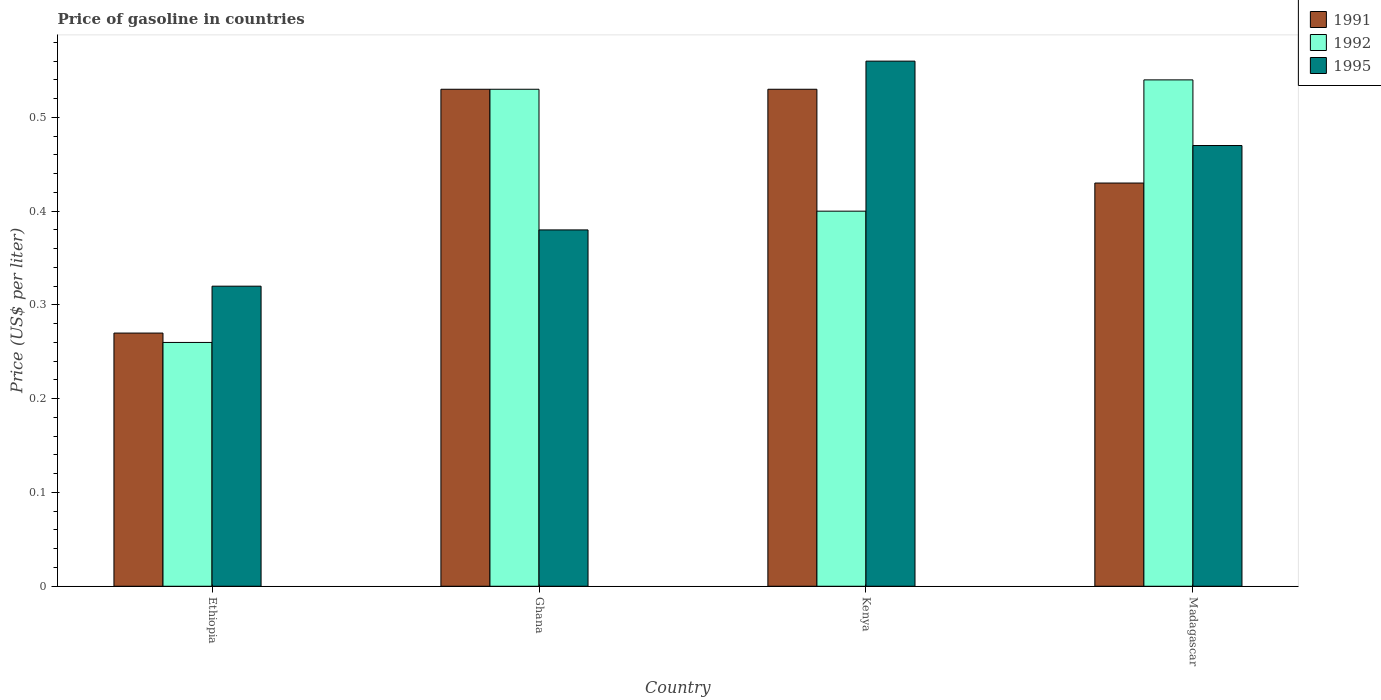How many different coloured bars are there?
Provide a succinct answer. 3. Are the number of bars on each tick of the X-axis equal?
Your answer should be compact. Yes. What is the label of the 1st group of bars from the left?
Ensure brevity in your answer.  Ethiopia. What is the price of gasoline in 1991 in Ghana?
Your answer should be compact. 0.53. Across all countries, what is the maximum price of gasoline in 1992?
Give a very brief answer. 0.54. Across all countries, what is the minimum price of gasoline in 1995?
Ensure brevity in your answer.  0.32. In which country was the price of gasoline in 1995 maximum?
Provide a succinct answer. Kenya. In which country was the price of gasoline in 1995 minimum?
Offer a very short reply. Ethiopia. What is the total price of gasoline in 1995 in the graph?
Provide a short and direct response. 1.73. What is the difference between the price of gasoline in 1995 in Kenya and that in Madagascar?
Provide a succinct answer. 0.09. What is the difference between the price of gasoline in 1991 in Madagascar and the price of gasoline in 1995 in Ghana?
Ensure brevity in your answer.  0.05. What is the average price of gasoline in 1995 per country?
Your answer should be compact. 0.43. What is the difference between the price of gasoline of/in 1991 and price of gasoline of/in 1992 in Madagascar?
Your answer should be compact. -0.11. What is the ratio of the price of gasoline in 1992 in Ghana to that in Kenya?
Ensure brevity in your answer.  1.32. Is the difference between the price of gasoline in 1991 in Ethiopia and Ghana greater than the difference between the price of gasoline in 1992 in Ethiopia and Ghana?
Your answer should be compact. Yes. What is the difference between the highest and the second highest price of gasoline in 1991?
Provide a succinct answer. 0.1. What is the difference between the highest and the lowest price of gasoline in 1995?
Offer a terse response. 0.24. In how many countries, is the price of gasoline in 1995 greater than the average price of gasoline in 1995 taken over all countries?
Your response must be concise. 2. Is the sum of the price of gasoline in 1992 in Ghana and Madagascar greater than the maximum price of gasoline in 1991 across all countries?
Your answer should be very brief. Yes. What does the 2nd bar from the left in Ghana represents?
Provide a short and direct response. 1992. Is it the case that in every country, the sum of the price of gasoline in 1991 and price of gasoline in 1995 is greater than the price of gasoline in 1992?
Make the answer very short. Yes. How many bars are there?
Your response must be concise. 12. How many countries are there in the graph?
Keep it short and to the point. 4. Does the graph contain any zero values?
Your answer should be compact. No. Where does the legend appear in the graph?
Give a very brief answer. Top right. How many legend labels are there?
Your answer should be compact. 3. What is the title of the graph?
Keep it short and to the point. Price of gasoline in countries. What is the label or title of the X-axis?
Your response must be concise. Country. What is the label or title of the Y-axis?
Your answer should be very brief. Price (US$ per liter). What is the Price (US$ per liter) in 1991 in Ethiopia?
Provide a short and direct response. 0.27. What is the Price (US$ per liter) in 1992 in Ethiopia?
Provide a succinct answer. 0.26. What is the Price (US$ per liter) of 1995 in Ethiopia?
Keep it short and to the point. 0.32. What is the Price (US$ per liter) in 1991 in Ghana?
Offer a very short reply. 0.53. What is the Price (US$ per liter) of 1992 in Ghana?
Your answer should be very brief. 0.53. What is the Price (US$ per liter) of 1995 in Ghana?
Provide a succinct answer. 0.38. What is the Price (US$ per liter) of 1991 in Kenya?
Give a very brief answer. 0.53. What is the Price (US$ per liter) of 1992 in Kenya?
Offer a very short reply. 0.4. What is the Price (US$ per liter) of 1995 in Kenya?
Keep it short and to the point. 0.56. What is the Price (US$ per liter) of 1991 in Madagascar?
Make the answer very short. 0.43. What is the Price (US$ per liter) in 1992 in Madagascar?
Give a very brief answer. 0.54. What is the Price (US$ per liter) of 1995 in Madagascar?
Give a very brief answer. 0.47. Across all countries, what is the maximum Price (US$ per liter) of 1991?
Your answer should be very brief. 0.53. Across all countries, what is the maximum Price (US$ per liter) of 1992?
Your answer should be very brief. 0.54. Across all countries, what is the maximum Price (US$ per liter) in 1995?
Offer a terse response. 0.56. Across all countries, what is the minimum Price (US$ per liter) in 1991?
Offer a terse response. 0.27. Across all countries, what is the minimum Price (US$ per liter) of 1992?
Offer a very short reply. 0.26. Across all countries, what is the minimum Price (US$ per liter) in 1995?
Your answer should be very brief. 0.32. What is the total Price (US$ per liter) of 1991 in the graph?
Provide a short and direct response. 1.76. What is the total Price (US$ per liter) of 1992 in the graph?
Offer a very short reply. 1.73. What is the total Price (US$ per liter) in 1995 in the graph?
Keep it short and to the point. 1.73. What is the difference between the Price (US$ per liter) in 1991 in Ethiopia and that in Ghana?
Offer a terse response. -0.26. What is the difference between the Price (US$ per liter) of 1992 in Ethiopia and that in Ghana?
Offer a terse response. -0.27. What is the difference between the Price (US$ per liter) of 1995 in Ethiopia and that in Ghana?
Ensure brevity in your answer.  -0.06. What is the difference between the Price (US$ per liter) in 1991 in Ethiopia and that in Kenya?
Your answer should be compact. -0.26. What is the difference between the Price (US$ per liter) of 1992 in Ethiopia and that in Kenya?
Provide a short and direct response. -0.14. What is the difference between the Price (US$ per liter) of 1995 in Ethiopia and that in Kenya?
Offer a terse response. -0.24. What is the difference between the Price (US$ per liter) in 1991 in Ethiopia and that in Madagascar?
Make the answer very short. -0.16. What is the difference between the Price (US$ per liter) of 1992 in Ethiopia and that in Madagascar?
Your answer should be compact. -0.28. What is the difference between the Price (US$ per liter) of 1992 in Ghana and that in Kenya?
Your answer should be very brief. 0.13. What is the difference between the Price (US$ per liter) in 1995 in Ghana and that in Kenya?
Your answer should be compact. -0.18. What is the difference between the Price (US$ per liter) of 1991 in Ghana and that in Madagascar?
Keep it short and to the point. 0.1. What is the difference between the Price (US$ per liter) of 1992 in Ghana and that in Madagascar?
Give a very brief answer. -0.01. What is the difference between the Price (US$ per liter) of 1995 in Ghana and that in Madagascar?
Offer a very short reply. -0.09. What is the difference between the Price (US$ per liter) of 1991 in Kenya and that in Madagascar?
Your response must be concise. 0.1. What is the difference between the Price (US$ per liter) in 1992 in Kenya and that in Madagascar?
Offer a very short reply. -0.14. What is the difference between the Price (US$ per liter) in 1995 in Kenya and that in Madagascar?
Offer a terse response. 0.09. What is the difference between the Price (US$ per liter) of 1991 in Ethiopia and the Price (US$ per liter) of 1992 in Ghana?
Ensure brevity in your answer.  -0.26. What is the difference between the Price (US$ per liter) of 1991 in Ethiopia and the Price (US$ per liter) of 1995 in Ghana?
Make the answer very short. -0.11. What is the difference between the Price (US$ per liter) in 1992 in Ethiopia and the Price (US$ per liter) in 1995 in Ghana?
Keep it short and to the point. -0.12. What is the difference between the Price (US$ per liter) in 1991 in Ethiopia and the Price (US$ per liter) in 1992 in Kenya?
Make the answer very short. -0.13. What is the difference between the Price (US$ per liter) of 1991 in Ethiopia and the Price (US$ per liter) of 1995 in Kenya?
Your answer should be very brief. -0.29. What is the difference between the Price (US$ per liter) in 1991 in Ethiopia and the Price (US$ per liter) in 1992 in Madagascar?
Your answer should be compact. -0.27. What is the difference between the Price (US$ per liter) of 1991 in Ethiopia and the Price (US$ per liter) of 1995 in Madagascar?
Provide a short and direct response. -0.2. What is the difference between the Price (US$ per liter) of 1992 in Ethiopia and the Price (US$ per liter) of 1995 in Madagascar?
Keep it short and to the point. -0.21. What is the difference between the Price (US$ per liter) in 1991 in Ghana and the Price (US$ per liter) in 1992 in Kenya?
Keep it short and to the point. 0.13. What is the difference between the Price (US$ per liter) in 1991 in Ghana and the Price (US$ per liter) in 1995 in Kenya?
Give a very brief answer. -0.03. What is the difference between the Price (US$ per liter) of 1992 in Ghana and the Price (US$ per liter) of 1995 in Kenya?
Your answer should be very brief. -0.03. What is the difference between the Price (US$ per liter) of 1991 in Ghana and the Price (US$ per liter) of 1992 in Madagascar?
Keep it short and to the point. -0.01. What is the difference between the Price (US$ per liter) of 1991 in Ghana and the Price (US$ per liter) of 1995 in Madagascar?
Offer a terse response. 0.06. What is the difference between the Price (US$ per liter) of 1992 in Ghana and the Price (US$ per liter) of 1995 in Madagascar?
Provide a short and direct response. 0.06. What is the difference between the Price (US$ per liter) in 1991 in Kenya and the Price (US$ per liter) in 1992 in Madagascar?
Give a very brief answer. -0.01. What is the difference between the Price (US$ per liter) of 1991 in Kenya and the Price (US$ per liter) of 1995 in Madagascar?
Offer a terse response. 0.06. What is the difference between the Price (US$ per liter) of 1992 in Kenya and the Price (US$ per liter) of 1995 in Madagascar?
Your answer should be very brief. -0.07. What is the average Price (US$ per liter) in 1991 per country?
Ensure brevity in your answer.  0.44. What is the average Price (US$ per liter) in 1992 per country?
Provide a succinct answer. 0.43. What is the average Price (US$ per liter) in 1995 per country?
Provide a succinct answer. 0.43. What is the difference between the Price (US$ per liter) of 1991 and Price (US$ per liter) of 1995 in Ethiopia?
Ensure brevity in your answer.  -0.05. What is the difference between the Price (US$ per liter) of 1992 and Price (US$ per liter) of 1995 in Ethiopia?
Offer a terse response. -0.06. What is the difference between the Price (US$ per liter) of 1991 and Price (US$ per liter) of 1995 in Ghana?
Offer a very short reply. 0.15. What is the difference between the Price (US$ per liter) in 1992 and Price (US$ per liter) in 1995 in Ghana?
Keep it short and to the point. 0.15. What is the difference between the Price (US$ per liter) in 1991 and Price (US$ per liter) in 1992 in Kenya?
Your answer should be compact. 0.13. What is the difference between the Price (US$ per liter) in 1991 and Price (US$ per liter) in 1995 in Kenya?
Give a very brief answer. -0.03. What is the difference between the Price (US$ per liter) in 1992 and Price (US$ per liter) in 1995 in Kenya?
Your answer should be very brief. -0.16. What is the difference between the Price (US$ per liter) of 1991 and Price (US$ per liter) of 1992 in Madagascar?
Offer a terse response. -0.11. What is the difference between the Price (US$ per liter) in 1991 and Price (US$ per liter) in 1995 in Madagascar?
Your answer should be very brief. -0.04. What is the difference between the Price (US$ per liter) of 1992 and Price (US$ per liter) of 1995 in Madagascar?
Keep it short and to the point. 0.07. What is the ratio of the Price (US$ per liter) in 1991 in Ethiopia to that in Ghana?
Ensure brevity in your answer.  0.51. What is the ratio of the Price (US$ per liter) of 1992 in Ethiopia to that in Ghana?
Offer a terse response. 0.49. What is the ratio of the Price (US$ per liter) of 1995 in Ethiopia to that in Ghana?
Keep it short and to the point. 0.84. What is the ratio of the Price (US$ per liter) of 1991 in Ethiopia to that in Kenya?
Ensure brevity in your answer.  0.51. What is the ratio of the Price (US$ per liter) of 1992 in Ethiopia to that in Kenya?
Give a very brief answer. 0.65. What is the ratio of the Price (US$ per liter) of 1995 in Ethiopia to that in Kenya?
Your response must be concise. 0.57. What is the ratio of the Price (US$ per liter) in 1991 in Ethiopia to that in Madagascar?
Your response must be concise. 0.63. What is the ratio of the Price (US$ per liter) in 1992 in Ethiopia to that in Madagascar?
Make the answer very short. 0.48. What is the ratio of the Price (US$ per liter) of 1995 in Ethiopia to that in Madagascar?
Ensure brevity in your answer.  0.68. What is the ratio of the Price (US$ per liter) of 1992 in Ghana to that in Kenya?
Provide a short and direct response. 1.32. What is the ratio of the Price (US$ per liter) of 1995 in Ghana to that in Kenya?
Provide a succinct answer. 0.68. What is the ratio of the Price (US$ per liter) of 1991 in Ghana to that in Madagascar?
Offer a very short reply. 1.23. What is the ratio of the Price (US$ per liter) of 1992 in Ghana to that in Madagascar?
Keep it short and to the point. 0.98. What is the ratio of the Price (US$ per liter) in 1995 in Ghana to that in Madagascar?
Your answer should be compact. 0.81. What is the ratio of the Price (US$ per liter) of 1991 in Kenya to that in Madagascar?
Your answer should be compact. 1.23. What is the ratio of the Price (US$ per liter) in 1992 in Kenya to that in Madagascar?
Offer a very short reply. 0.74. What is the ratio of the Price (US$ per liter) in 1995 in Kenya to that in Madagascar?
Offer a very short reply. 1.19. What is the difference between the highest and the second highest Price (US$ per liter) of 1992?
Provide a short and direct response. 0.01. What is the difference between the highest and the second highest Price (US$ per liter) in 1995?
Your answer should be compact. 0.09. What is the difference between the highest and the lowest Price (US$ per liter) in 1991?
Keep it short and to the point. 0.26. What is the difference between the highest and the lowest Price (US$ per liter) of 1992?
Make the answer very short. 0.28. What is the difference between the highest and the lowest Price (US$ per liter) of 1995?
Offer a very short reply. 0.24. 